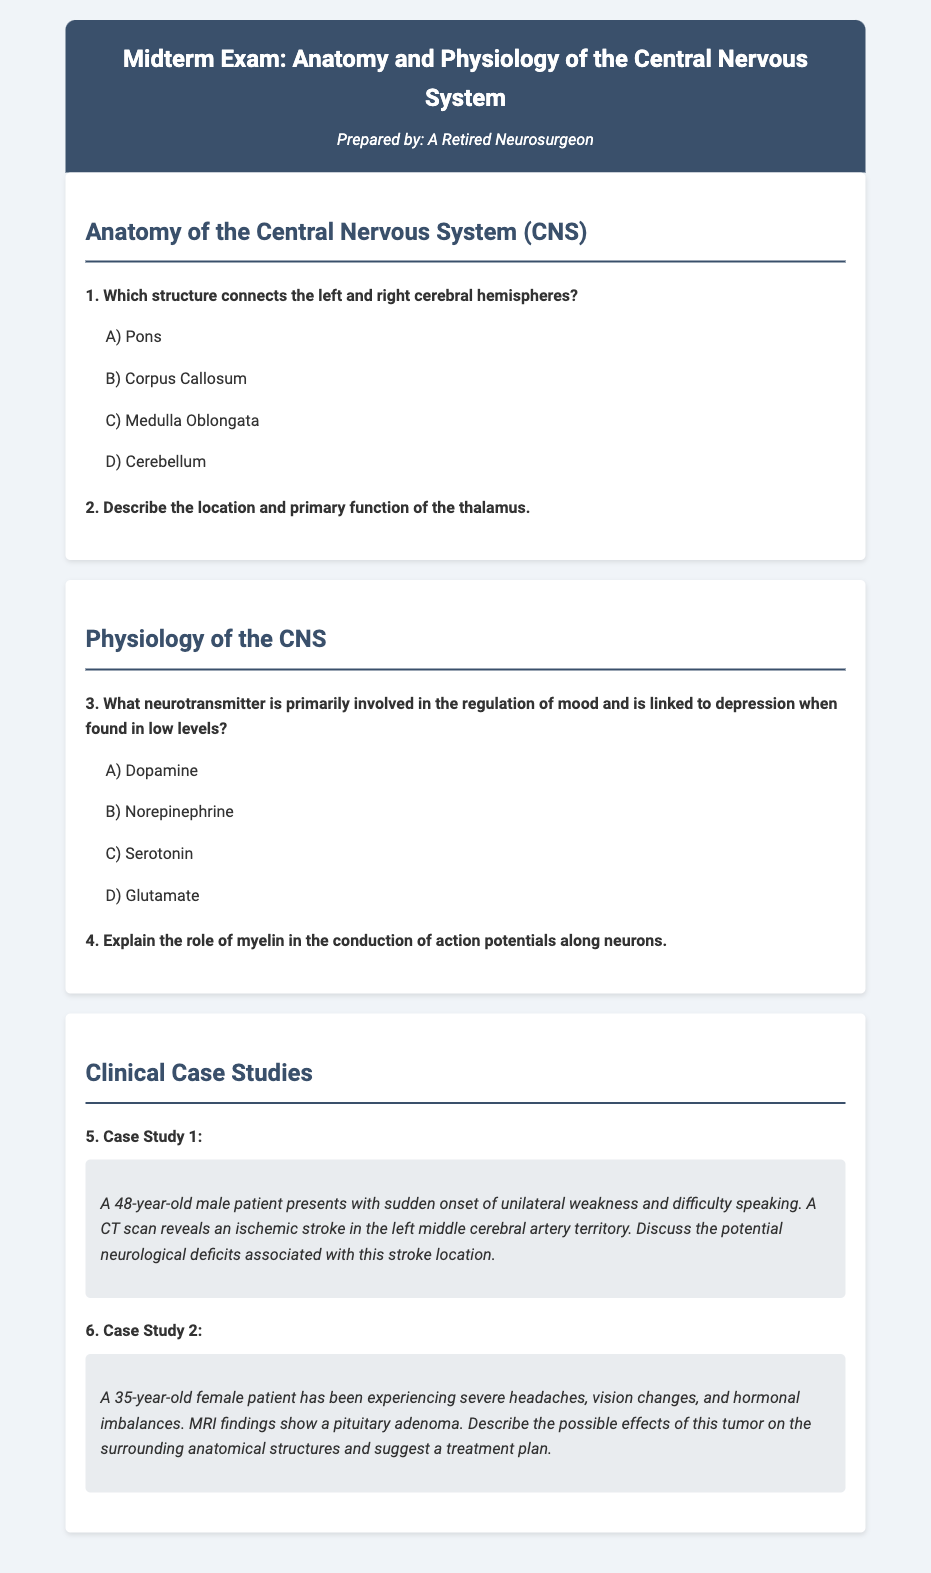1. Which structure connects the left and right cerebral hemispheres? The document mentions a question asking which structure connects the left and right cerebral hemispheres, providing multiple-choice options.
Answer: Corpus Callosum 2. What neurotransmitter is primarily involved in the regulation of mood? The document contains a question regarding the neurotransmitter involved in mood regulation, listing options to choose from.
Answer: Serotonin 3. What is the age of the male patient in Case Study 1? The document states that the male patient presenting with a stroke is 48 years old.
Answer: 48 4. What findings were revealed by the CT scan in Case Study 1? The document describes that a CT scan reveals an ischemic stroke in a specific location in the brain.
Answer: Ischemic stroke 5. Describe the patient symptoms in Case Study 2. The document lists symptoms experienced by the female patient in Case Study 2, requesting a description.
Answer: Severe headaches, vision changes, hormonal imbalances 6. What type of tumor is discussed in Case Study 2? The document refers to a specific type of tumor that affects the female patient in Case Study 2.
Answer: Pituitary adenoma 7. What artery territory is affected in Case Study 1? The document indicates the specific artery territory impacted by the ischemic stroke in the case study.
Answer: Left middle cerebral artery territory 8. Explain the potential neurological deficits associated with the stroke location. The document encourages a discussion about the consequences of a stroke in a particular area of the brain.
Answer: Varies 9. What is the proposed treatment plan suggested for the patient in Case Study 2? The document requests a suggestion for a treatment plan related to a specific medical issue presented.
Answer: Suggest a treatment plan 10. What is the primary function of the thalamus? The document asks for a description of the thalamus's location and primary function.
Answer: Varies 